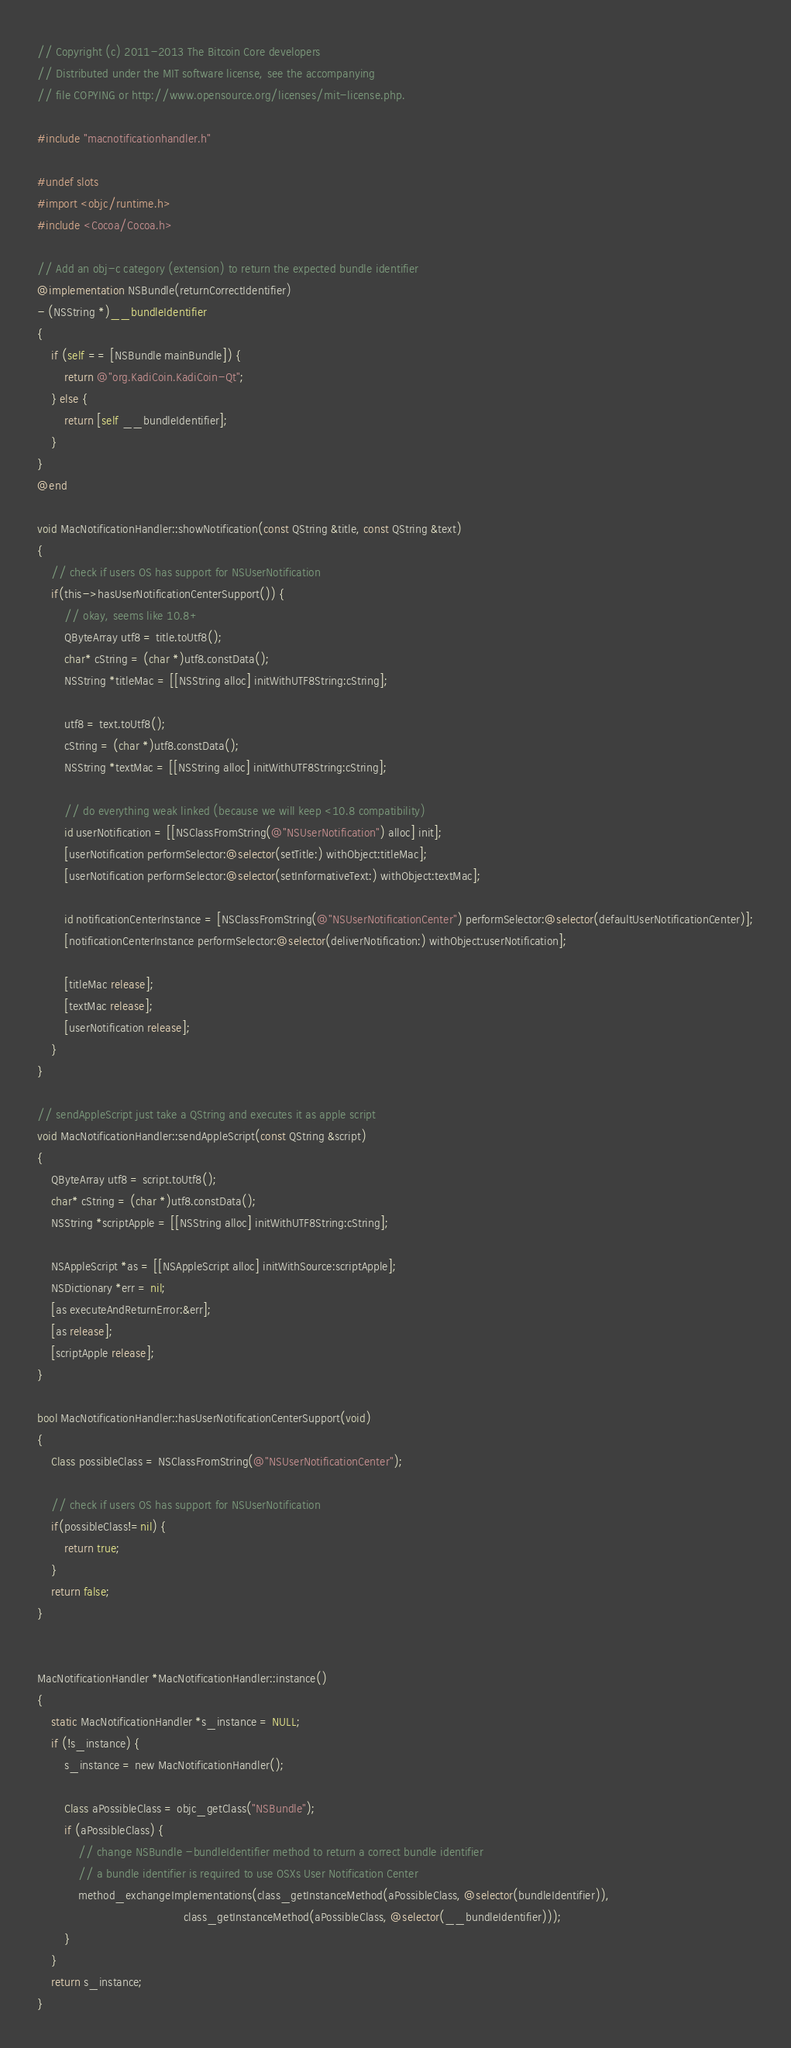Convert code to text. <code><loc_0><loc_0><loc_500><loc_500><_ObjectiveC_>// Copyright (c) 2011-2013 The Bitcoin Core developers
// Distributed under the MIT software license, see the accompanying
// file COPYING or http://www.opensource.org/licenses/mit-license.php.

#include "macnotificationhandler.h"

#undef slots
#import <objc/runtime.h>
#include <Cocoa/Cocoa.h>

// Add an obj-c category (extension) to return the expected bundle identifier
@implementation NSBundle(returnCorrectIdentifier)
- (NSString *)__bundleIdentifier
{
    if (self == [NSBundle mainBundle]) {
        return @"org.KadiCoin.KadiCoin-Qt";
    } else {
        return [self __bundleIdentifier];
    }
}
@end

void MacNotificationHandler::showNotification(const QString &title, const QString &text)
{
    // check if users OS has support for NSUserNotification
    if(this->hasUserNotificationCenterSupport()) {
        // okay, seems like 10.8+
        QByteArray utf8 = title.toUtf8();
        char* cString = (char *)utf8.constData();
        NSString *titleMac = [[NSString alloc] initWithUTF8String:cString];

        utf8 = text.toUtf8();
        cString = (char *)utf8.constData();
        NSString *textMac = [[NSString alloc] initWithUTF8String:cString];

        // do everything weak linked (because we will keep <10.8 compatibility)
        id userNotification = [[NSClassFromString(@"NSUserNotification") alloc] init];
        [userNotification performSelector:@selector(setTitle:) withObject:titleMac];
        [userNotification performSelector:@selector(setInformativeText:) withObject:textMac];

        id notificationCenterInstance = [NSClassFromString(@"NSUserNotificationCenter") performSelector:@selector(defaultUserNotificationCenter)];
        [notificationCenterInstance performSelector:@selector(deliverNotification:) withObject:userNotification];

        [titleMac release];
        [textMac release];
        [userNotification release];
    }
}

// sendAppleScript just take a QString and executes it as apple script
void MacNotificationHandler::sendAppleScript(const QString &script)
{
    QByteArray utf8 = script.toUtf8();
    char* cString = (char *)utf8.constData();
    NSString *scriptApple = [[NSString alloc] initWithUTF8String:cString];

    NSAppleScript *as = [[NSAppleScript alloc] initWithSource:scriptApple];
    NSDictionary *err = nil;
    [as executeAndReturnError:&err];
    [as release];
    [scriptApple release];
}

bool MacNotificationHandler::hasUserNotificationCenterSupport(void)
{
    Class possibleClass = NSClassFromString(@"NSUserNotificationCenter");

    // check if users OS has support for NSUserNotification
    if(possibleClass!=nil) {
        return true;
    }
    return false;
}


MacNotificationHandler *MacNotificationHandler::instance()
{
    static MacNotificationHandler *s_instance = NULL;
    if (!s_instance) {
        s_instance = new MacNotificationHandler();
        
        Class aPossibleClass = objc_getClass("NSBundle");
        if (aPossibleClass) {
            // change NSBundle -bundleIdentifier method to return a correct bundle identifier
            // a bundle identifier is required to use OSXs User Notification Center
            method_exchangeImplementations(class_getInstanceMethod(aPossibleClass, @selector(bundleIdentifier)),
                                           class_getInstanceMethod(aPossibleClass, @selector(__bundleIdentifier)));
        }
    }
    return s_instance;
}
</code> 